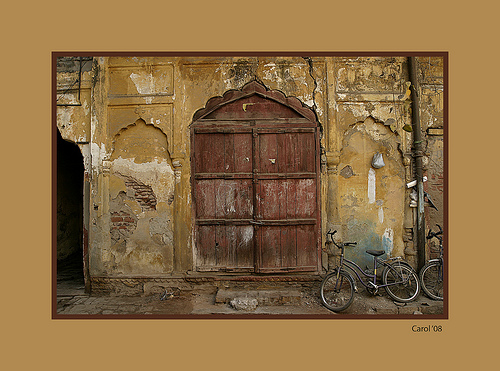Please provide the bounding box coordinate of the region this sentence describes: a wooden door. The wooden door is located at coordinates [0.4, 0.31, 0.66, 0.72], covering the central part of the weathered facade. 